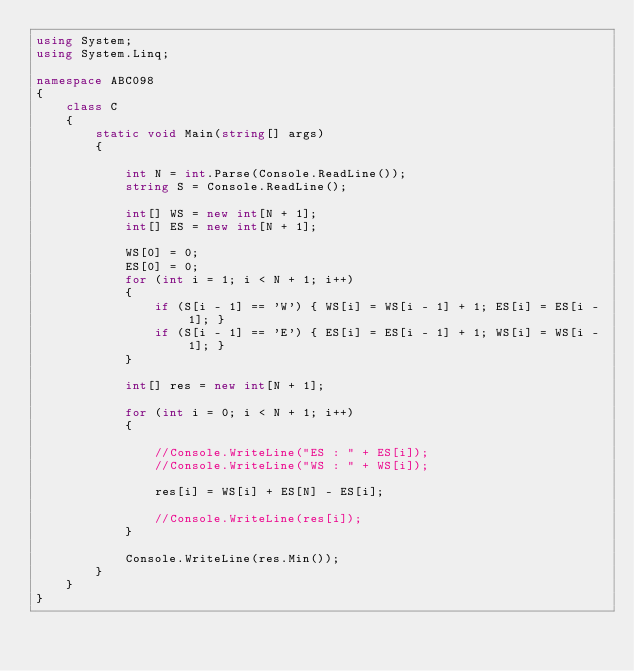Convert code to text. <code><loc_0><loc_0><loc_500><loc_500><_C#_>using System;
using System.Linq;

namespace ABC098
{
    class C
    {
        static void Main(string[] args)
        {

            int N = int.Parse(Console.ReadLine());
            string S = Console.ReadLine();

            int[] WS = new int[N + 1];
            int[] ES = new int[N + 1];

            WS[0] = 0;
            ES[0] = 0;
            for (int i = 1; i < N + 1; i++)
            {
                if (S[i - 1] == 'W') { WS[i] = WS[i - 1] + 1; ES[i] = ES[i - 1]; }
                if (S[i - 1] == 'E') { ES[i] = ES[i - 1] + 1; WS[i] = WS[i - 1]; }
            }

            int[] res = new int[N + 1];

            for (int i = 0; i < N + 1; i++)
            {

                //Console.WriteLine("ES : " + ES[i]);
                //Console.WriteLine("WS : " + WS[i]);

                res[i] = WS[i] + ES[N] - ES[i];

                //Console.WriteLine(res[i]);
            }

            Console.WriteLine(res.Min());
        }
    }
}
</code> 